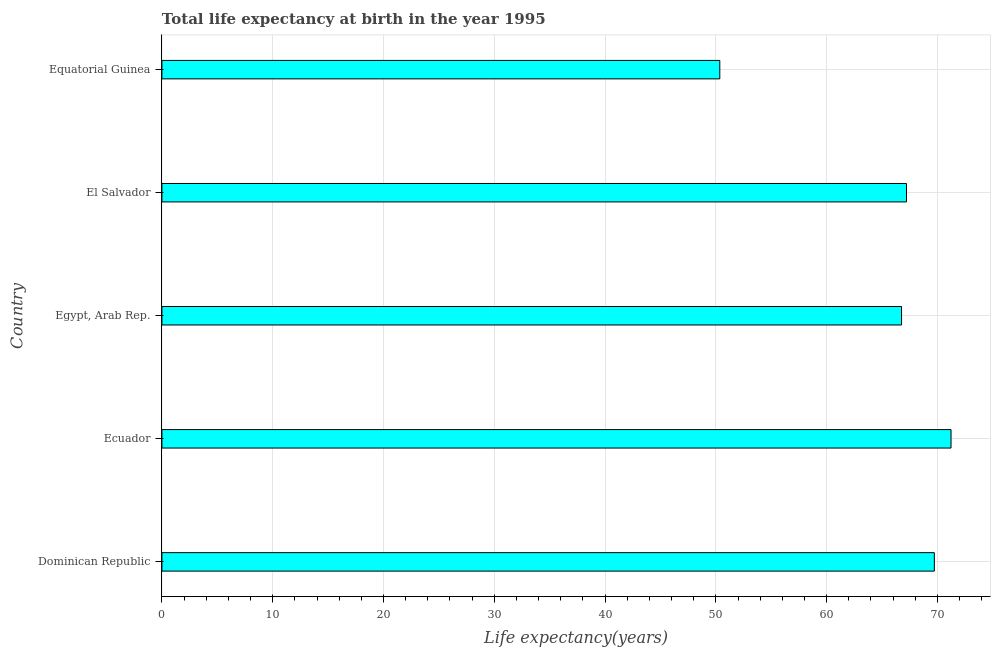Does the graph contain grids?
Ensure brevity in your answer.  Yes. What is the title of the graph?
Offer a very short reply. Total life expectancy at birth in the year 1995. What is the label or title of the X-axis?
Provide a succinct answer. Life expectancy(years). What is the life expectancy at birth in Equatorial Guinea?
Offer a terse response. 50.35. Across all countries, what is the maximum life expectancy at birth?
Make the answer very short. 71.23. Across all countries, what is the minimum life expectancy at birth?
Make the answer very short. 50.35. In which country was the life expectancy at birth maximum?
Provide a succinct answer. Ecuador. In which country was the life expectancy at birth minimum?
Offer a terse response. Equatorial Guinea. What is the sum of the life expectancy at birth?
Your answer should be compact. 325.27. What is the difference between the life expectancy at birth in Egypt, Arab Rep. and El Salvador?
Provide a short and direct response. -0.45. What is the average life expectancy at birth per country?
Ensure brevity in your answer.  65.05. What is the median life expectancy at birth?
Your answer should be compact. 67.21. In how many countries, is the life expectancy at birth greater than 6 years?
Your answer should be compact. 5. What is the ratio of the life expectancy at birth in Dominican Republic to that in Egypt, Arab Rep.?
Keep it short and to the point. 1.04. Is the life expectancy at birth in Dominican Republic less than that in Ecuador?
Your answer should be very brief. Yes. Is the difference between the life expectancy at birth in Egypt, Arab Rep. and El Salvador greater than the difference between any two countries?
Provide a succinct answer. No. What is the difference between the highest and the second highest life expectancy at birth?
Your answer should be very brief. 1.51. Is the sum of the life expectancy at birth in Dominican Republic and Equatorial Guinea greater than the maximum life expectancy at birth across all countries?
Your answer should be very brief. Yes. What is the difference between the highest and the lowest life expectancy at birth?
Keep it short and to the point. 20.87. What is the Life expectancy(years) of Dominican Republic?
Provide a short and direct response. 69.72. What is the Life expectancy(years) in Ecuador?
Provide a short and direct response. 71.23. What is the Life expectancy(years) in Egypt, Arab Rep.?
Ensure brevity in your answer.  66.76. What is the Life expectancy(years) of El Salvador?
Offer a very short reply. 67.21. What is the Life expectancy(years) of Equatorial Guinea?
Keep it short and to the point. 50.35. What is the difference between the Life expectancy(years) in Dominican Republic and Ecuador?
Give a very brief answer. -1.51. What is the difference between the Life expectancy(years) in Dominican Republic and Egypt, Arab Rep.?
Make the answer very short. 2.96. What is the difference between the Life expectancy(years) in Dominican Republic and El Salvador?
Your response must be concise. 2.52. What is the difference between the Life expectancy(years) in Dominican Republic and Equatorial Guinea?
Keep it short and to the point. 19.37. What is the difference between the Life expectancy(years) in Ecuador and Egypt, Arab Rep.?
Provide a succinct answer. 4.47. What is the difference between the Life expectancy(years) in Ecuador and El Salvador?
Ensure brevity in your answer.  4.02. What is the difference between the Life expectancy(years) in Ecuador and Equatorial Guinea?
Your answer should be compact. 20.87. What is the difference between the Life expectancy(years) in Egypt, Arab Rep. and El Salvador?
Offer a terse response. -0.44. What is the difference between the Life expectancy(years) in Egypt, Arab Rep. and Equatorial Guinea?
Offer a very short reply. 16.41. What is the difference between the Life expectancy(years) in El Salvador and Equatorial Guinea?
Keep it short and to the point. 16.85. What is the ratio of the Life expectancy(years) in Dominican Republic to that in Ecuador?
Offer a very short reply. 0.98. What is the ratio of the Life expectancy(years) in Dominican Republic to that in Egypt, Arab Rep.?
Ensure brevity in your answer.  1.04. What is the ratio of the Life expectancy(years) in Dominican Republic to that in El Salvador?
Offer a very short reply. 1.04. What is the ratio of the Life expectancy(years) in Dominican Republic to that in Equatorial Guinea?
Provide a succinct answer. 1.39. What is the ratio of the Life expectancy(years) in Ecuador to that in Egypt, Arab Rep.?
Provide a short and direct response. 1.07. What is the ratio of the Life expectancy(years) in Ecuador to that in El Salvador?
Your answer should be compact. 1.06. What is the ratio of the Life expectancy(years) in Ecuador to that in Equatorial Guinea?
Ensure brevity in your answer.  1.41. What is the ratio of the Life expectancy(years) in Egypt, Arab Rep. to that in El Salvador?
Provide a succinct answer. 0.99. What is the ratio of the Life expectancy(years) in Egypt, Arab Rep. to that in Equatorial Guinea?
Keep it short and to the point. 1.33. What is the ratio of the Life expectancy(years) in El Salvador to that in Equatorial Guinea?
Offer a terse response. 1.33. 